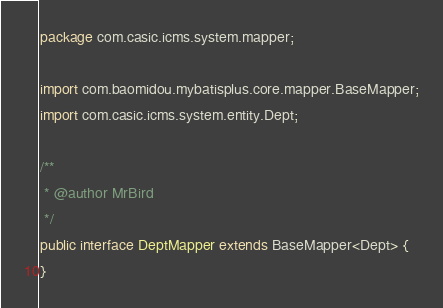<code> <loc_0><loc_0><loc_500><loc_500><_Java_>package com.casic.icms.system.mapper;

import com.baomidou.mybatisplus.core.mapper.BaseMapper;
import com.casic.icms.system.entity.Dept;

/**
 * @author MrBird
 */
public interface DeptMapper extends BaseMapper<Dept> {
}
</code> 